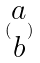Convert formula to latex. <formula><loc_0><loc_0><loc_500><loc_500>( \begin{matrix} a \\ b \end{matrix} )</formula> 